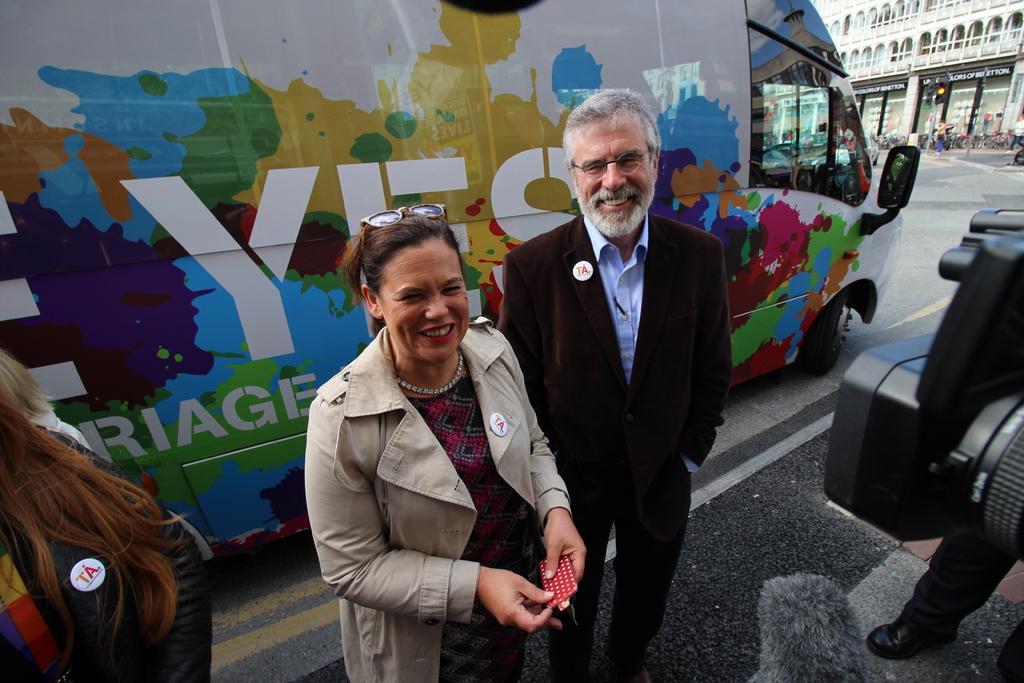Could you give a brief overview of what you see in this image? In this picture I can see a vehicle with some text on it and I can see few people are standing and I can see a camera on the right side and I can see another human legs at the bottom right corner and I can see building and few boards with some text. 